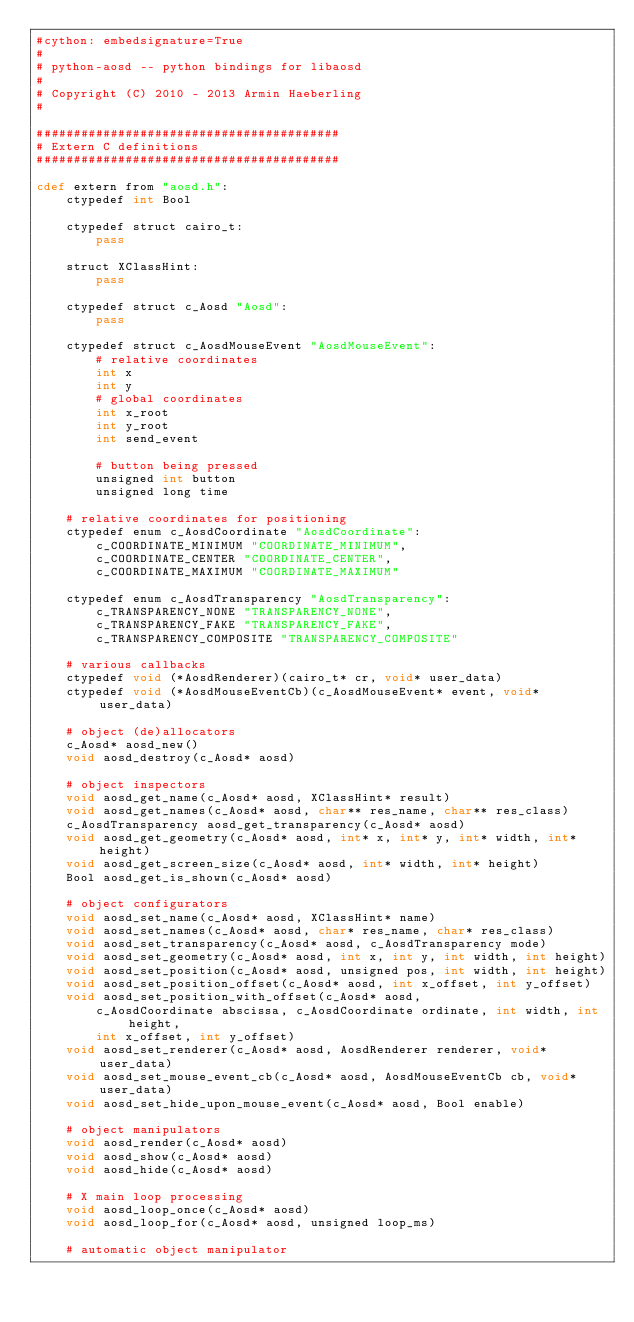<code> <loc_0><loc_0><loc_500><loc_500><_Cython_>#cython: embedsignature=True
#
# python-aosd -- python bindings for libaosd
#
# Copyright (C) 2010 - 2013 Armin Haeberling
#

#########################################
# Extern C definitions
#########################################

cdef extern from "aosd.h":
    ctypedef int Bool

    ctypedef struct cairo_t:
        pass

    struct XClassHint:
        pass

    ctypedef struct c_Aosd "Aosd":
        pass

    ctypedef struct c_AosdMouseEvent "AosdMouseEvent":
        # relative coordinates
        int x
        int y
        # global coordinates
        int x_root
        int y_root
        int send_event

        # button being pressed
        unsigned int button
        unsigned long time

    # relative coordinates for positioning
    ctypedef enum c_AosdCoordinate "AosdCoordinate":
        c_COORDINATE_MINIMUM "COORDINATE_MINIMUM",
        c_COORDINATE_CENTER "COORDINATE_CENTER",
        c_COORDINATE_MAXIMUM "COORDINATE_MAXIMUM"

    ctypedef enum c_AosdTransparency "AosdTransparency":
        c_TRANSPARENCY_NONE "TRANSPARENCY_NONE",
        c_TRANSPARENCY_FAKE "TRANSPARENCY_FAKE",
        c_TRANSPARENCY_COMPOSITE "TRANSPARENCY_COMPOSITE"

    # various callbacks
    ctypedef void (*AosdRenderer)(cairo_t* cr, void* user_data)
    ctypedef void (*AosdMouseEventCb)(c_AosdMouseEvent* event, void* user_data)

    # object (de)allocators
    c_Aosd* aosd_new()
    void aosd_destroy(c_Aosd* aosd)

    # object inspectors
    void aosd_get_name(c_Aosd* aosd, XClassHint* result)
    void aosd_get_names(c_Aosd* aosd, char** res_name, char** res_class)
    c_AosdTransparency aosd_get_transparency(c_Aosd* aosd)
    void aosd_get_geometry(c_Aosd* aosd, int* x, int* y, int* width, int* height)
    void aosd_get_screen_size(c_Aosd* aosd, int* width, int* height)
    Bool aosd_get_is_shown(c_Aosd* aosd)

    # object configurators
    void aosd_set_name(c_Aosd* aosd, XClassHint* name)
    void aosd_set_names(c_Aosd* aosd, char* res_name, char* res_class)
    void aosd_set_transparency(c_Aosd* aosd, c_AosdTransparency mode)
    void aosd_set_geometry(c_Aosd* aosd, int x, int y, int width, int height)
    void aosd_set_position(c_Aosd* aosd, unsigned pos, int width, int height)
    void aosd_set_position_offset(c_Aosd* aosd, int x_offset, int y_offset)
    void aosd_set_position_with_offset(c_Aosd* aosd,
        c_AosdCoordinate abscissa, c_AosdCoordinate ordinate, int width, int height,
        int x_offset, int y_offset)
    void aosd_set_renderer(c_Aosd* aosd, AosdRenderer renderer, void* user_data)
    void aosd_set_mouse_event_cb(c_Aosd* aosd, AosdMouseEventCb cb, void* user_data)
    void aosd_set_hide_upon_mouse_event(c_Aosd* aosd, Bool enable)

    # object manipulators
    void aosd_render(c_Aosd* aosd)
    void aosd_show(c_Aosd* aosd)
    void aosd_hide(c_Aosd* aosd)

    # X main loop processing
    void aosd_loop_once(c_Aosd* aosd)
    void aosd_loop_for(c_Aosd* aosd, unsigned loop_ms)

    # automatic object manipulator</code> 